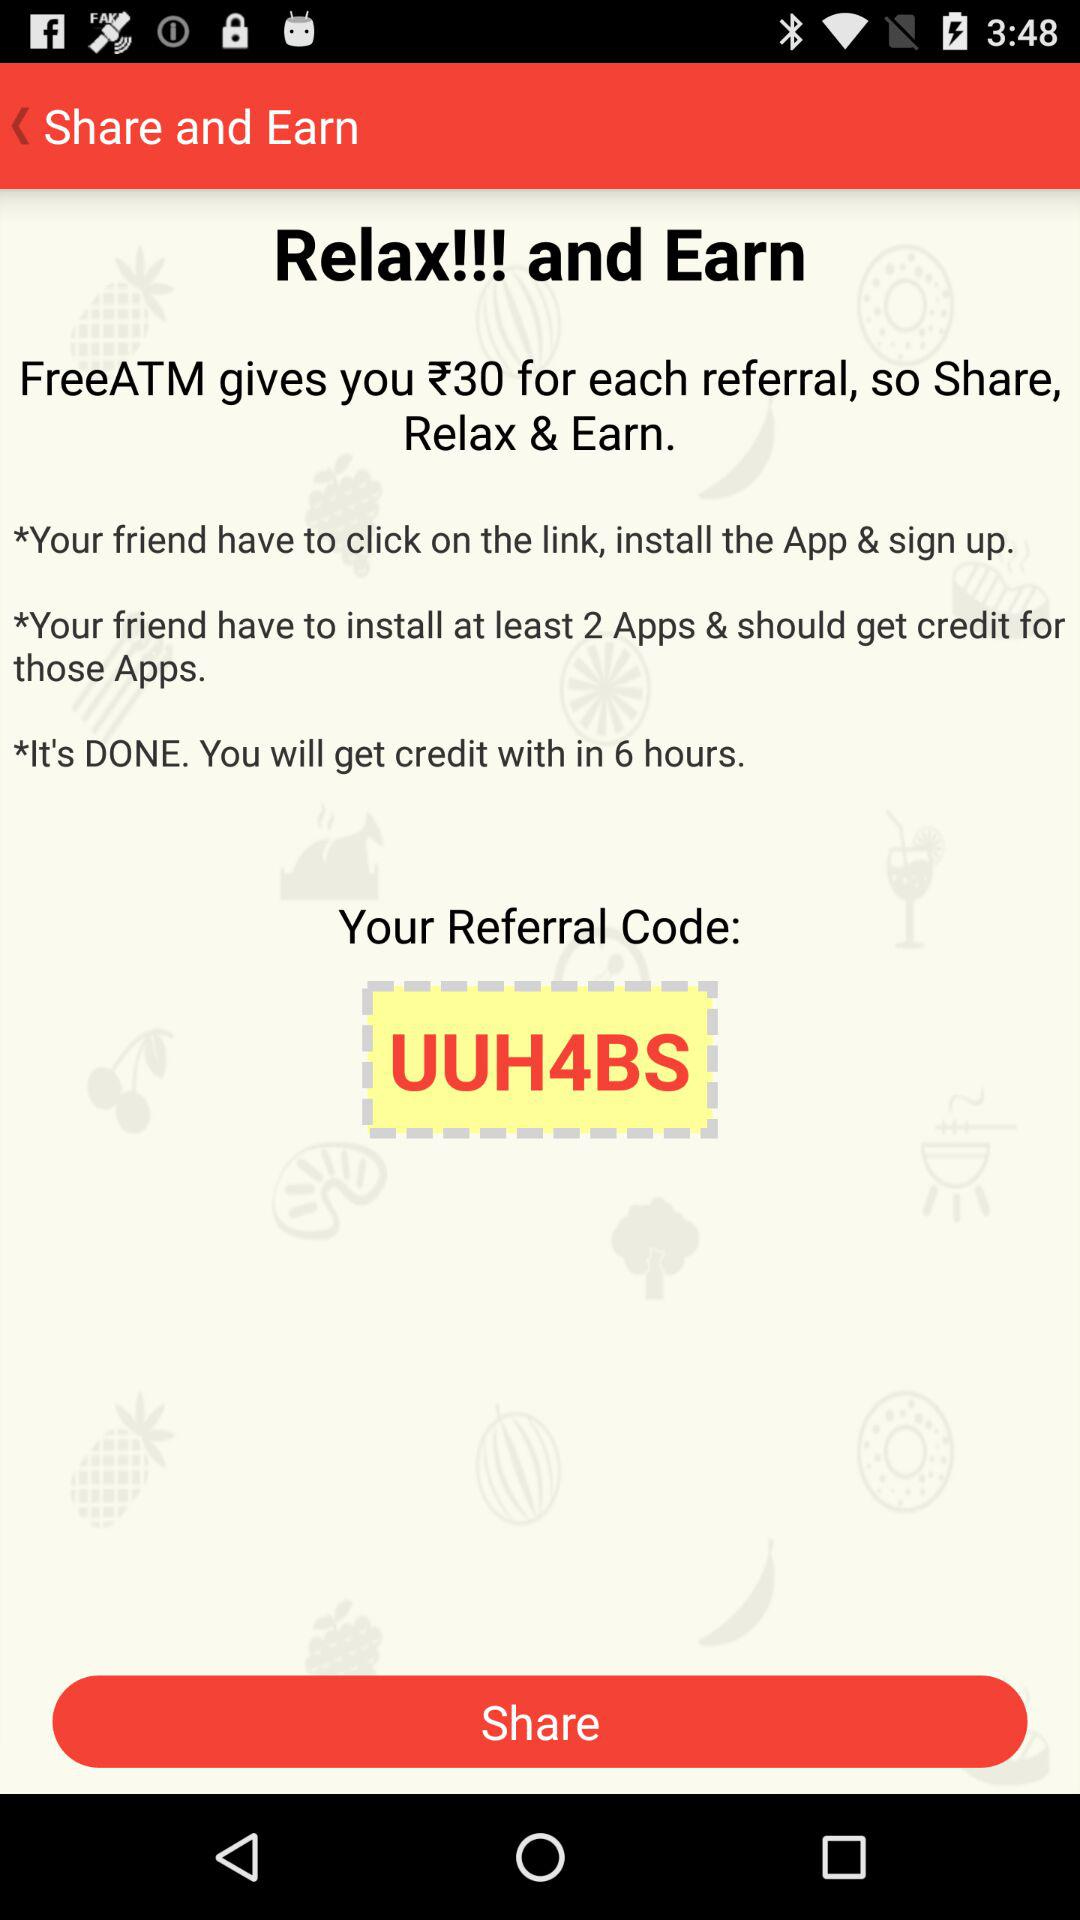How many minimal applications should be installed? There are 2 minimal applications. 